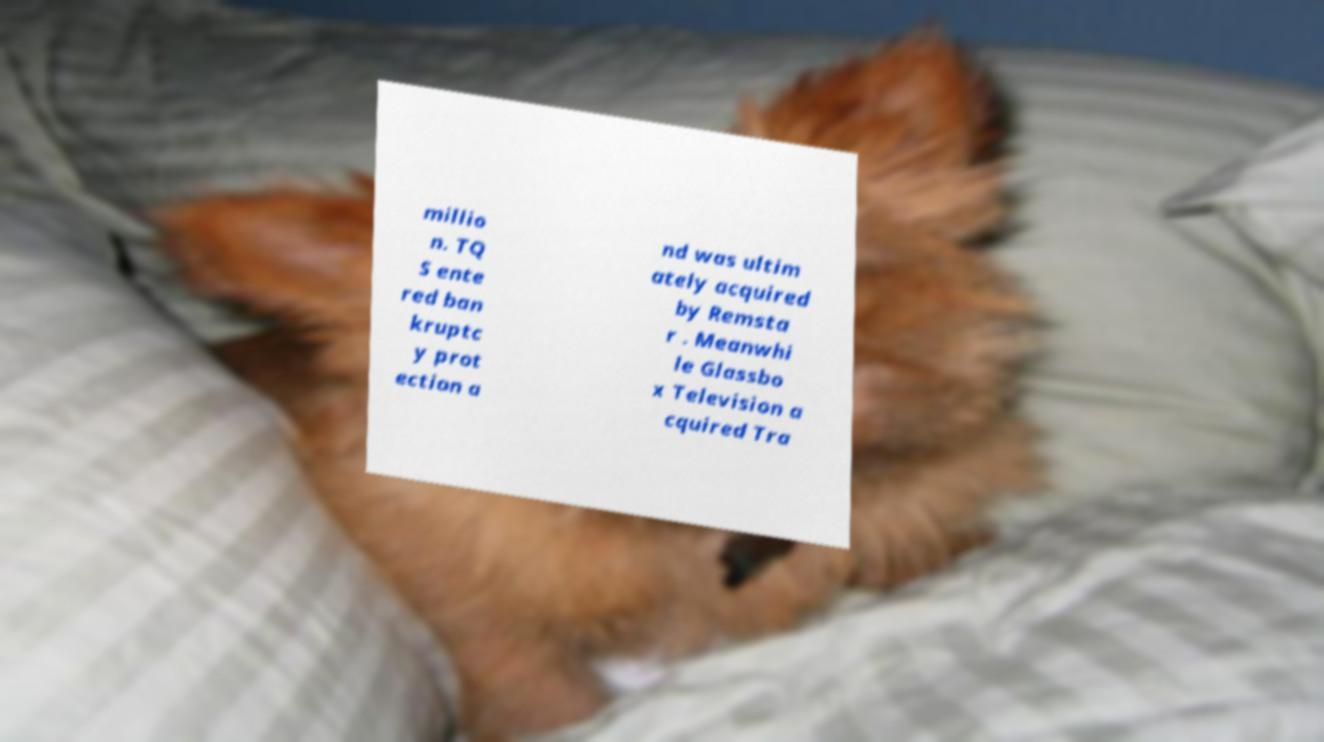Please identify and transcribe the text found in this image. millio n. TQ S ente red ban kruptc y prot ection a nd was ultim ately acquired by Remsta r . Meanwhi le Glassbo x Television a cquired Tra 